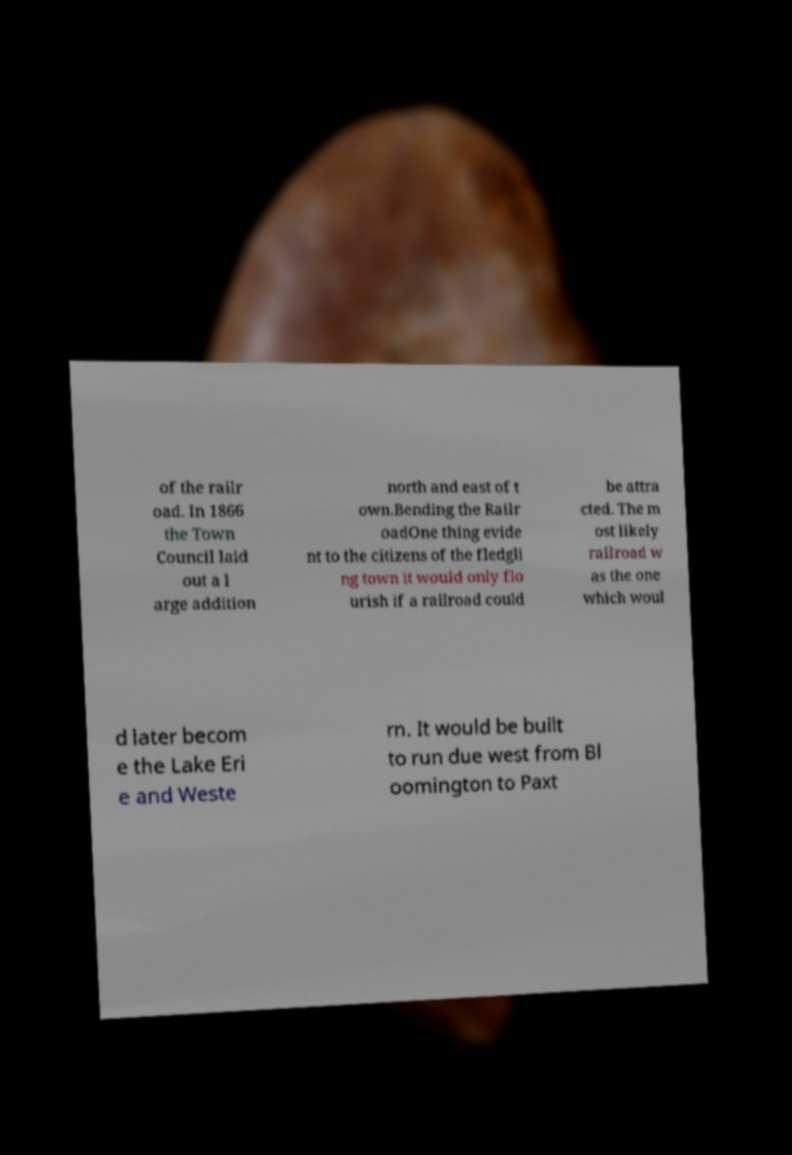Can you accurately transcribe the text from the provided image for me? of the railr oad. In 1866 the Town Council laid out a l arge addition north and east of t own.Bending the Railr oadOne thing evide nt to the citizens of the fledgli ng town it would only flo urish if a railroad could be attra cted. The m ost likely railroad w as the one which woul d later becom e the Lake Eri e and Weste rn. It would be built to run due west from Bl oomington to Paxt 